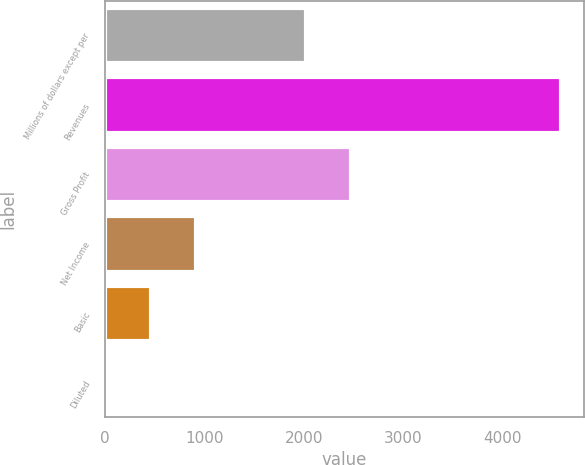Convert chart to OTSL. <chart><loc_0><loc_0><loc_500><loc_500><bar_chart><fcel>Millions of dollars except per<fcel>Revenues<fcel>Gross Profit<fcel>Net Income<fcel>Basic<fcel>Diluted<nl><fcel>2019<fcel>4584<fcel>2477.36<fcel>917.16<fcel>458.81<fcel>0.45<nl></chart> 